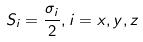Convert formula to latex. <formula><loc_0><loc_0><loc_500><loc_500>S _ { i } = \frac { \sigma _ { i } } { 2 } , i = x , y , z</formula> 